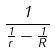<formula> <loc_0><loc_0><loc_500><loc_500>\frac { 1 } { \frac { 1 } { r } - \frac { 1 } { R } }</formula> 